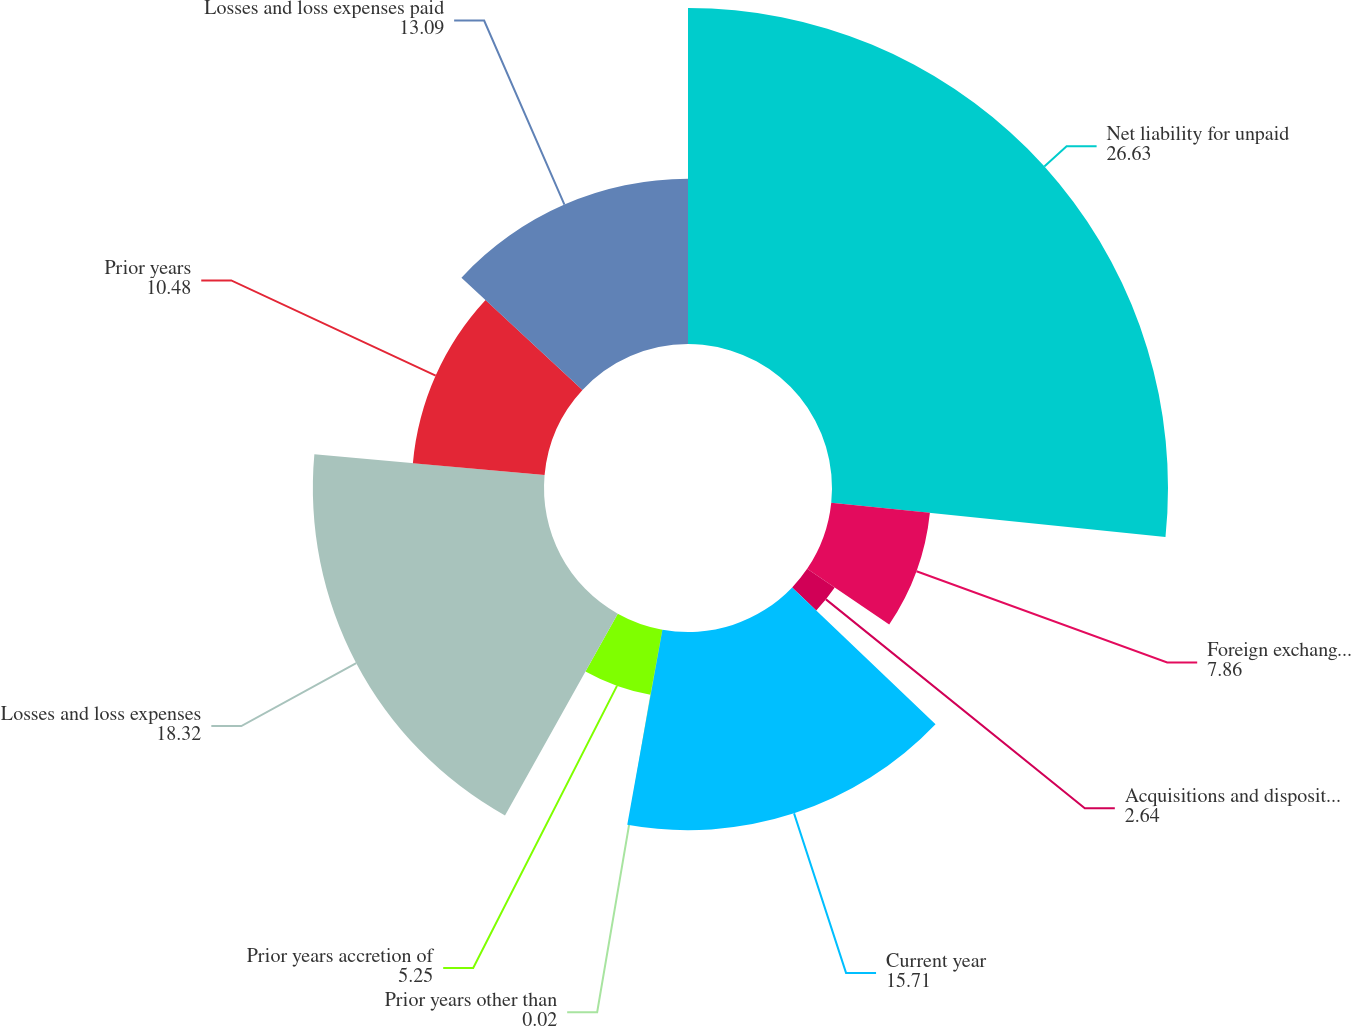Convert chart. <chart><loc_0><loc_0><loc_500><loc_500><pie_chart><fcel>Net liability for unpaid<fcel>Foreign exchange effect<fcel>Acquisitions and dispositions<fcel>Current year<fcel>Prior years other than<fcel>Prior years accretion of<fcel>Losses and loss expenses<fcel>Prior years<fcel>Losses and loss expenses paid<nl><fcel>26.63%<fcel>7.86%<fcel>2.64%<fcel>15.71%<fcel>0.02%<fcel>5.25%<fcel>18.32%<fcel>10.48%<fcel>13.09%<nl></chart> 